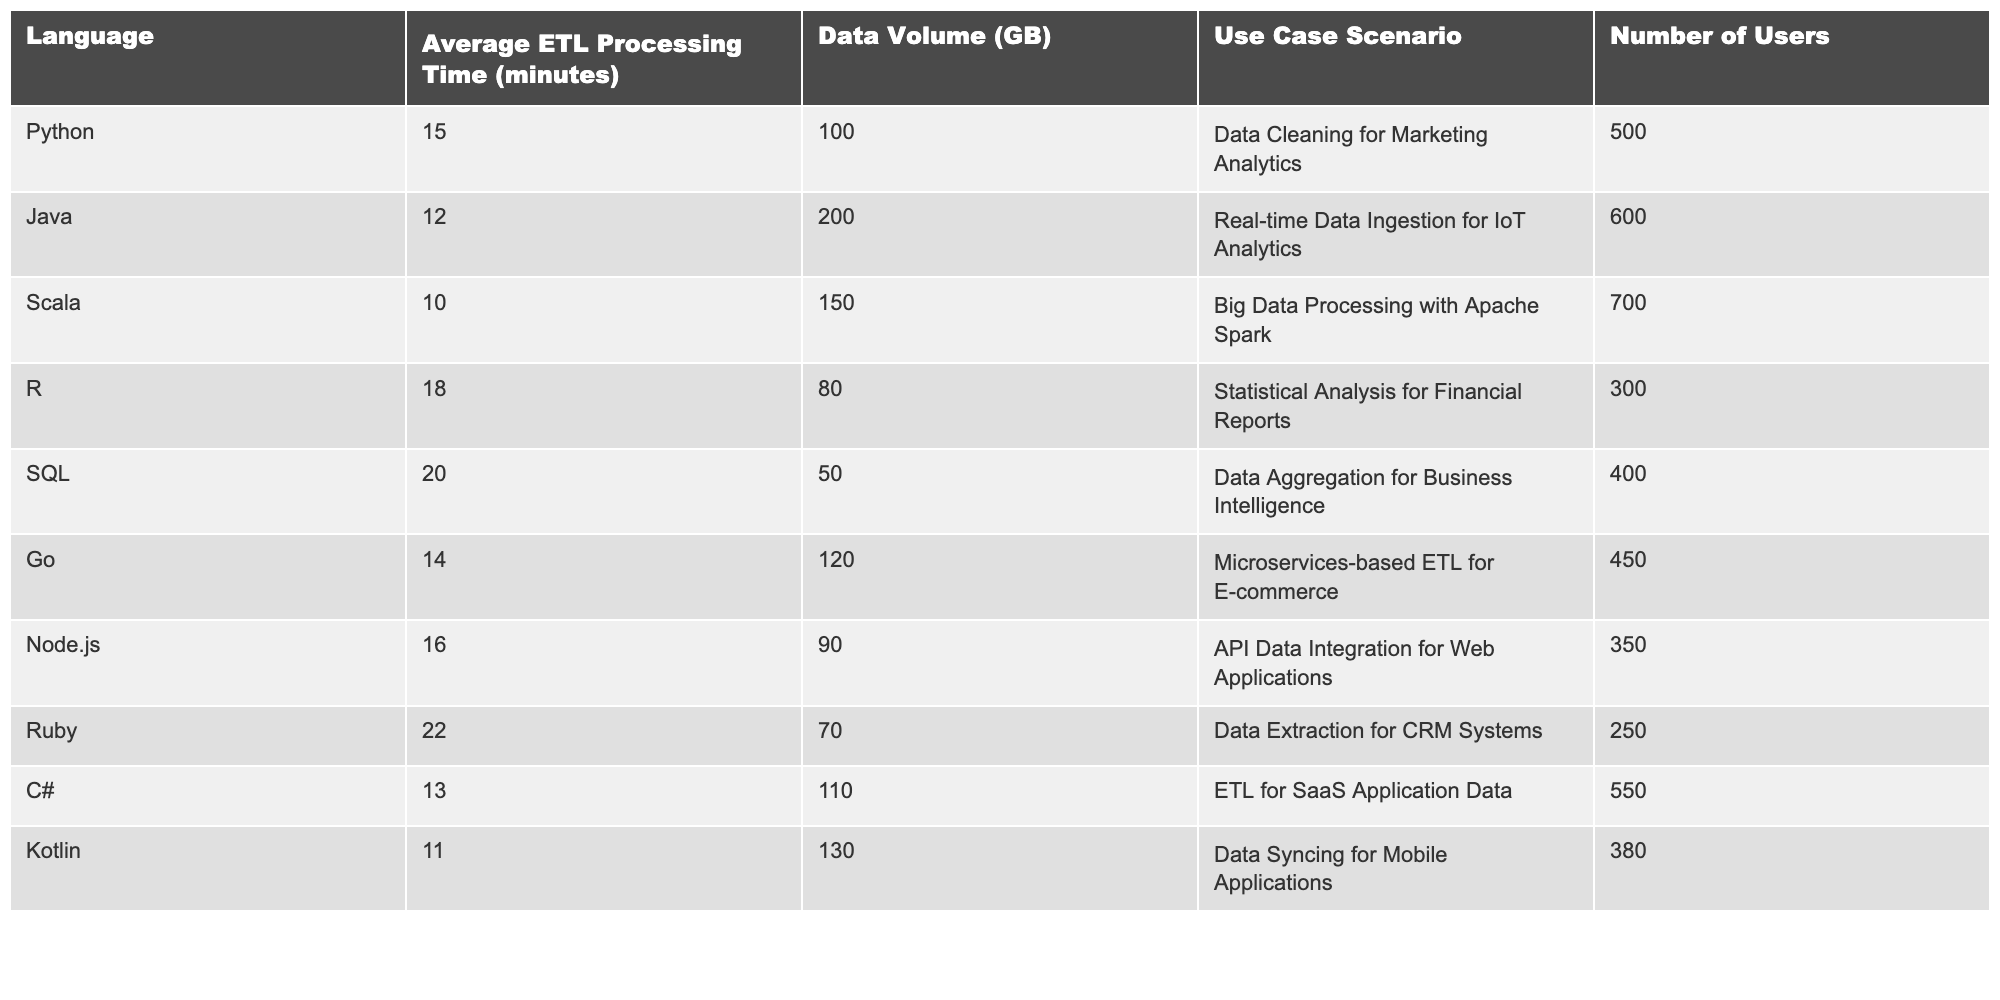What is the average ETL processing time for all languages combined? To find the average, sum the average processing times: (15 + 12 + 10 + 18 + 20 + 14 + 16 + 22 + 13 + 11) = 151. There are 10 languages, so the average is 151/10 = 15.1.
Answer: 15.1 Which language has the longest average ETL processing time? By reviewing the table, Ruby has the longest average processing time at 22 minutes.
Answer: Ruby What is the average data volume for ETL processes in Java and C#? The average data volume is calculated by adding the data volumes for Java (200 GB) and C# (110 GB), which totals 310 GB, and then dividing by 2. Therefore, the average is 310/2 = 155 GB.
Answer: 155 GB Is Python faster than SQL in terms of average ETL processing time? Python's average ETL processing time is 15 minutes, while SQL's is 20 minutes. Since 15 is less than 20, Python is indeed faster than SQL.
Answer: Yes What is the total data volume for the three languages with the shortest average ETL processing times? The languages with the shortest times are Scala (150 GB), Kotlin (130 GB), and Java (200 GB). Their total data volume is 150 + 130 + 200 = 480 GB.
Answer: 480 GB Which language has a data volume nearest to the average of all data volumes? The average data volume can be calculated by summing all data volumes: (100 + 200 + 150 + 80 + 50 + 120 + 90 + 70 + 110 + 130) = 1,100 GB. Dividing that by 10 gives an average of 110 GB. The language closest to this average is C# at 110 GB.
Answer: C# Are there more users for Java ETL processes than for Ruby ETL processes? Java has 600 users while Ruby has 250. Since 600 is greater than 250, there are indeed more users for Java.
Answer: Yes What is the percentage difference in average ETL processing time between the fastest (Scala) and the slowest (Ruby)? The fastest average ETL processing time is 10 minutes for Scala, and the slowest is 22 minutes for Ruby. The difference is 22 - 10 = 12 minutes. To find the percentage difference based on the slowest, (12/22) * 100% ≈ 54.55%.
Answer: 54.55% Which two languages have the closest average ETL processing times? By examining the table, C# has an average of 13 minutes, and Go has an average of 14 minutes, making them the closest with a difference of only 1 minute.
Answer: C# and Go How does the data volume of the ETL process in R compare to that in Go? R has a data volume of 80 GB, while Go has 120 GB. Since 80 is less than 120, R has a smaller data volume compared to Go.
Answer: Smaller 